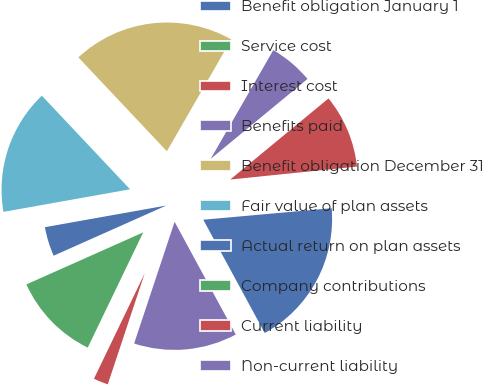Convert chart to OTSL. <chart><loc_0><loc_0><loc_500><loc_500><pie_chart><fcel>Benefit obligation January 1<fcel>Service cost<fcel>Interest cost<fcel>Benefits paid<fcel>Benefit obligation December 31<fcel>Fair value of plan assets<fcel>Actual return on plan assets<fcel>Company contributions<fcel>Current liability<fcel>Non-current liability<nl><fcel>18.51%<fcel>0.2%<fcel>9.36%<fcel>5.7%<fcel>20.34%<fcel>15.78%<fcel>3.86%<fcel>11.19%<fcel>2.03%<fcel>13.02%<nl></chart> 